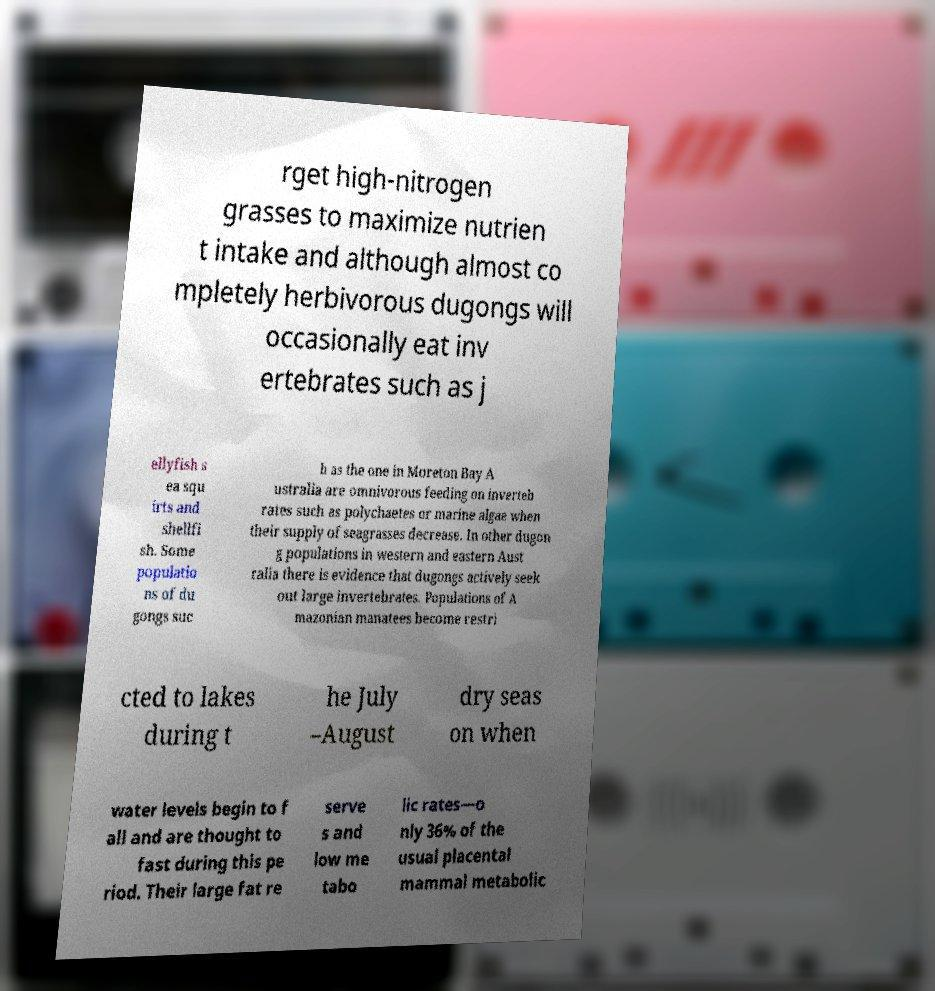Can you accurately transcribe the text from the provided image for me? rget high-nitrogen grasses to maximize nutrien t intake and although almost co mpletely herbivorous dugongs will occasionally eat inv ertebrates such as j ellyfish s ea squ irts and shellfi sh. Some populatio ns of du gongs suc h as the one in Moreton Bay A ustralia are omnivorous feeding on inverteb rates such as polychaetes or marine algae when their supply of seagrasses decrease. In other dugon g populations in western and eastern Aust ralia there is evidence that dugongs actively seek out large invertebrates. Populations of A mazonian manatees become restri cted to lakes during t he July –August dry seas on when water levels begin to f all and are thought to fast during this pe riod. Their large fat re serve s and low me tabo lic rates—o nly 36% of the usual placental mammal metabolic 